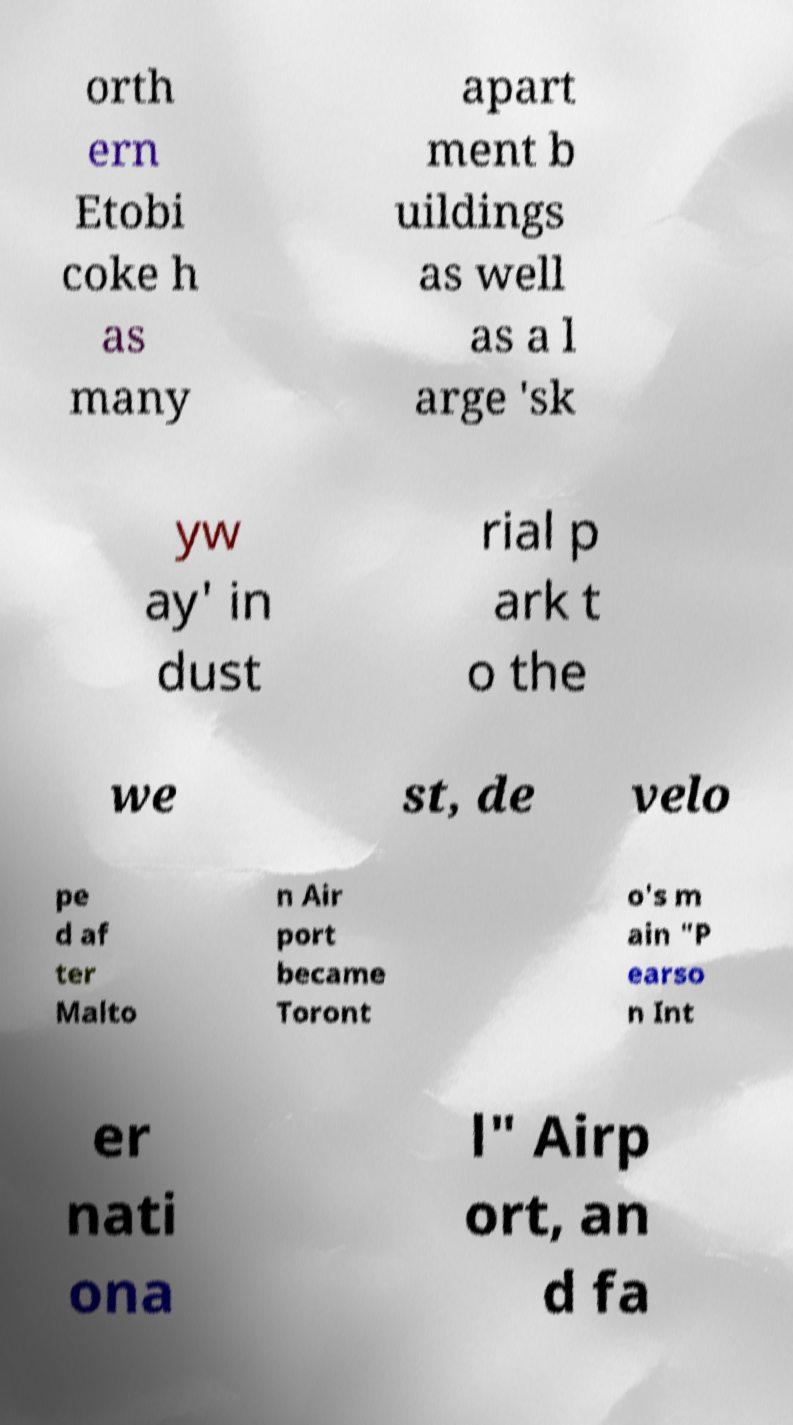There's text embedded in this image that I need extracted. Can you transcribe it verbatim? orth ern Etobi coke h as many apart ment b uildings as well as a l arge 'sk yw ay' in dust rial p ark t o the we st, de velo pe d af ter Malto n Air port became Toront o's m ain "P earso n Int er nati ona l" Airp ort, an d fa 